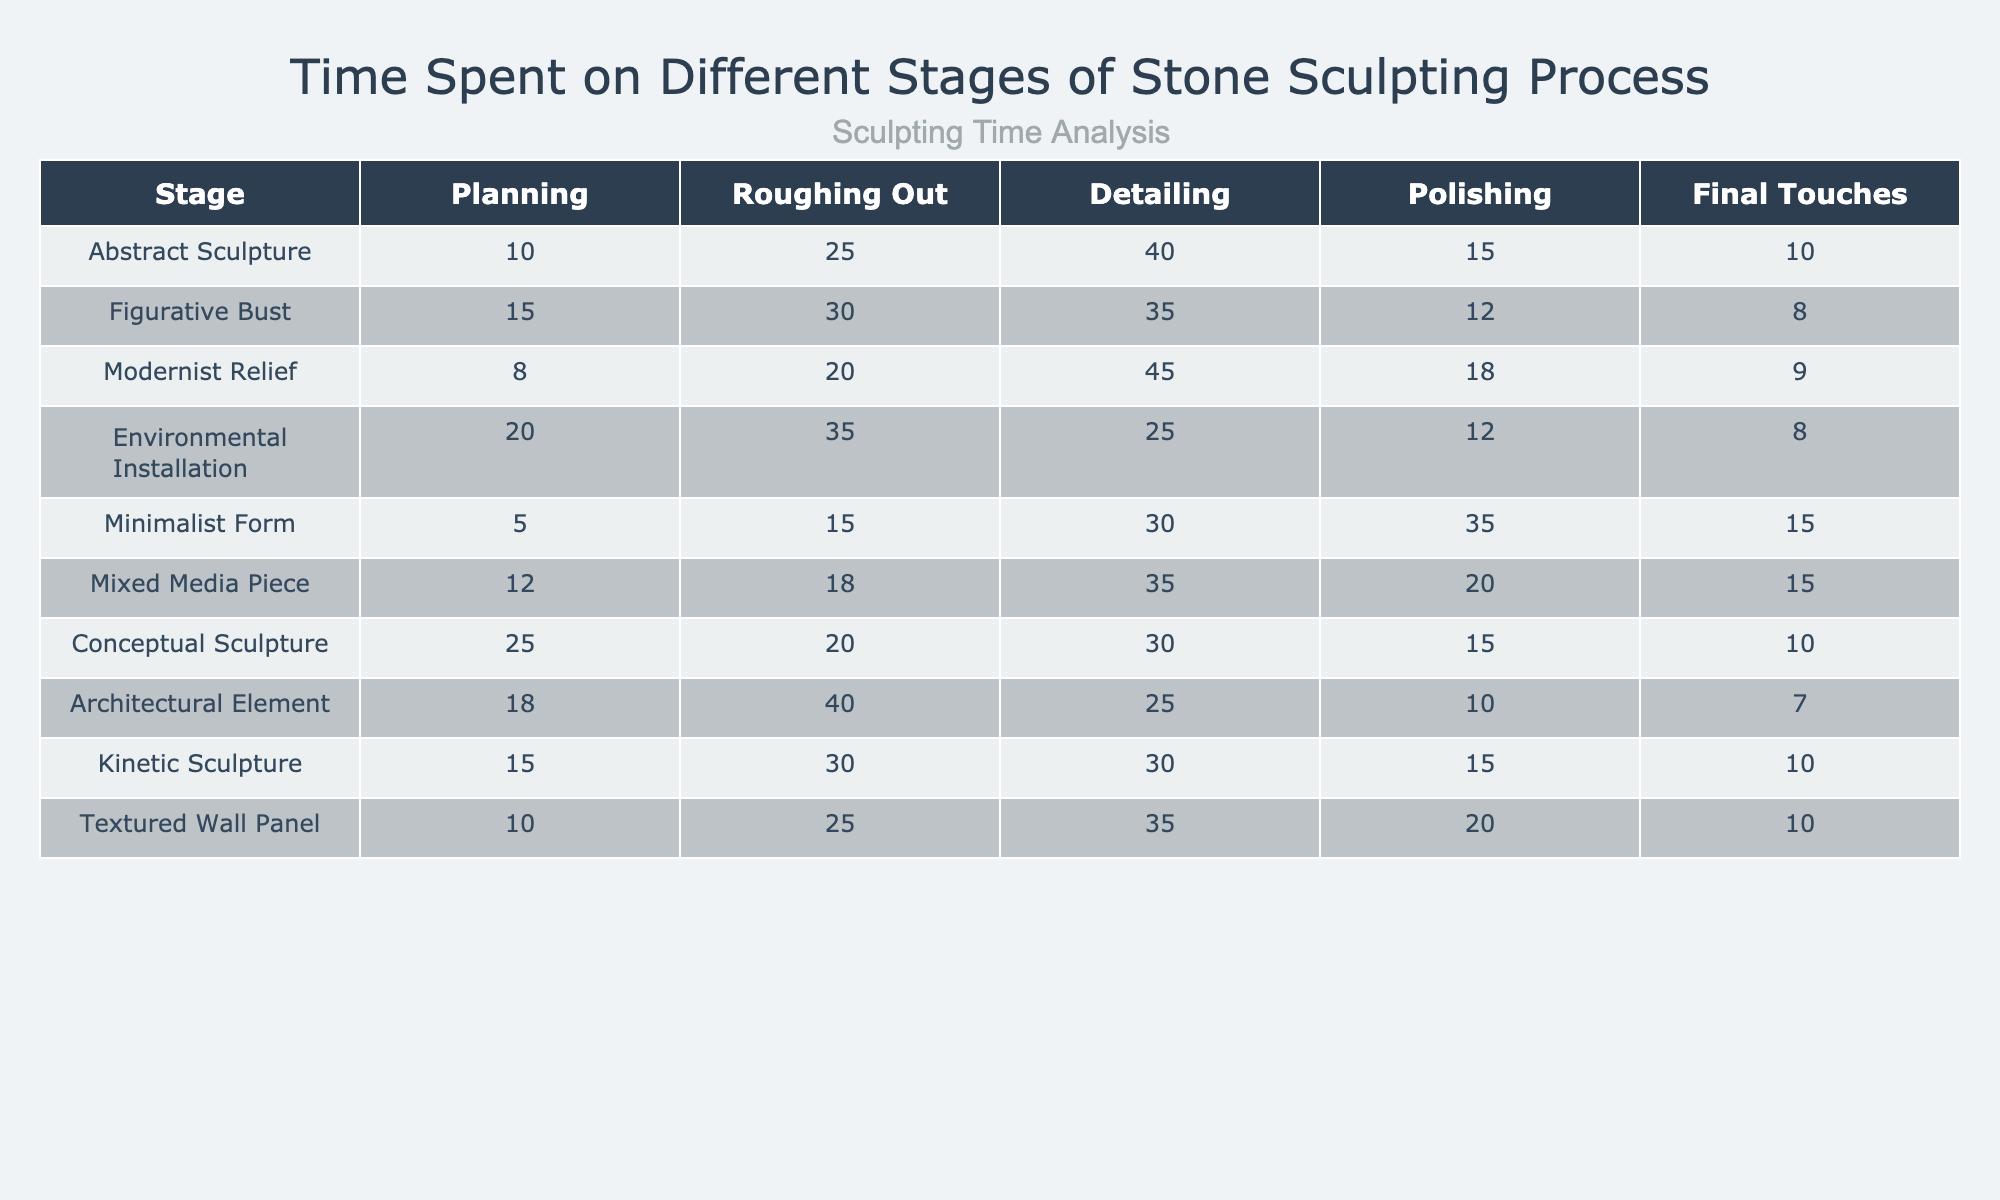What is the total time spent on the 'Detailing' stage for the 'Modernist Relief'? The time spent on the 'Detailing' stage for 'Modernist Relief' is listed as 45.
Answer: 45 Which sculpture type spends the least amount of time on the 'Final Touches'? The 'Architectural Element' spends 7 minutes on the 'Final Touches', which is the lowest compared to other types.
Answer: 7 What is the average time spent on the 'Polishing' stage across all sculptures? Adding up the times spent on polishing (15 + 12 + 18 + 12 + 35 + 20 + 15 + 10 + 15 + 20) gives a total of  165 minutes. There are 10 sculptures, so the average is 165/10 = 16.5 minutes.
Answer: 16.5 Is the time spent on 'Roughing Out' more than the time spent on 'Planning' for all sculpture types? No, in the cases 'Abstract Sculpture' and 'Minimalist Form', the time spent on 'Planning' is greater than 'Roughing Out'.
Answer: No Which sculpture type has the highest total time spent across all stages? The 'Mixed Media Piece' has a total of 100 minutes (12 + 18 + 35 + 20 + 15). This is verified by summing the minutes spent on each stage.
Answer: Mixed Media Piece What is the difference in time spent on the 'Detailing' stage between 'Figurative Bust' and 'Minimalist Form'? 'Figurative Bust' spends 35 minutes on 'Detailing', while 'Minimalist Form' spends 30 minutes. The difference is 35 - 30 = 5 minutes.
Answer: 5 Which sculpture type had the longest time spent on 'Planning'? The 'Conceptual Sculpture' had the longest time spent on 'Planning' at 25 minutes.
Answer: Conceptual Sculpture How many stages involve more than 20 minutes for 'Environmental Installation'? For 'Environmental Installation', the stages with more than 20 minutes are 'Planning' (20), 'Roughing Out' (35), and 'Detailing' (25), which total to three stages.
Answer: 3 Check if the time for 'Polishing' is ever greater than the time for 'Detailing' in any sculpture type. In 'Minimalist Form', the time for 'Polishing' is 35 minutes, which is more than the 30 minutes spent on 'Detailing'.
Answer: Yes What is the sculpture type with the most balanced time allocation across all stages? The 'Kinetic Sculpture' has a relatively even distribution across the stages, with times of 15, 30, 30, 15, and 10, indicating balanced time allocation.
Answer: Kinetic Sculpture 